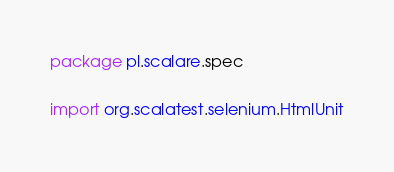Convert code to text. <code><loc_0><loc_0><loc_500><loc_500><_Scala_>package pl.scalare.spec

import org.scalatest.selenium.HtmlUnit</code> 